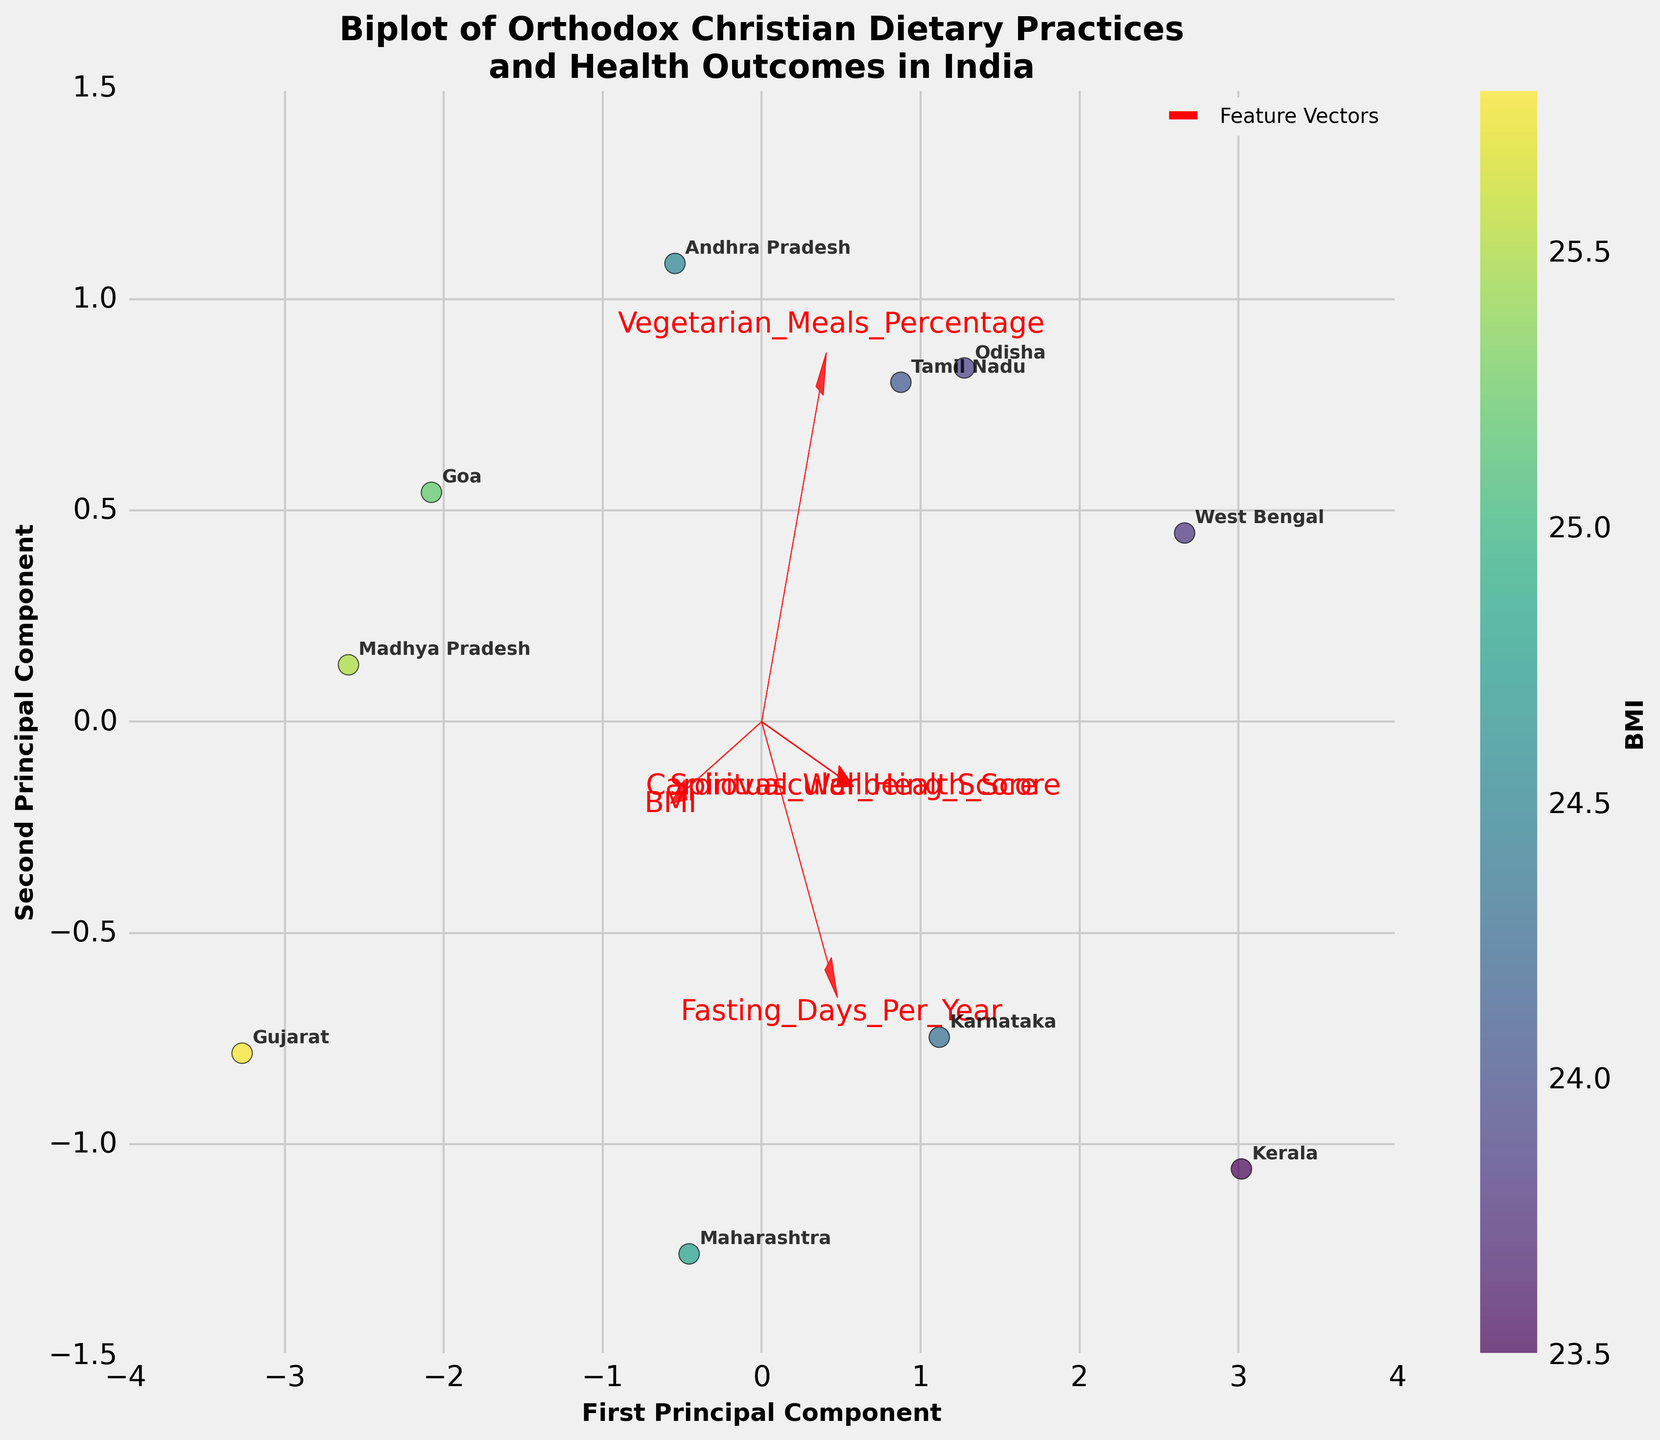What's the title of the figure? The title is located at the upper part of the figure, providing a clear indication of what the plot represents.
Answer: Biplot of Orthodox Christian Dietary Practices and Health Outcomes in India Which region has the highest BMI score based on the color shading? The regions are represented by different points, and the color coding indicates the BMI values, with a color bar beside the plot for reference. The darkest shade corresponds to the highest BMI.
Answer: Gujarat What are the two principal components labeled on the axes? The labels of the axes indicate which principal components are being plotted along each axis, usually with clear text.
Answer: First Principal Component and Second Principal Component Which feature vector has the largest positive value on the first principal component? Feature vectors are represented by arrows, with the direction and length indicating their relationship to the principal components. The feature vector extending furthest in the positive direction of the first principal component has the largest value.
Answer: Fasting_Days_Per_Year How many regions are plotted in the figure? Each region is represented by a labeled data point on the plot. Counting these labeled points provides the number of regions.
Answer: 10 Which region has the highest Spiritual Wellbeing Score? The data points are annotated with region labels, and the red feature vectors indicate how Spiritual Wellbeing Score is projected in the plot. The data point farthest in the positive direction of this vector corresponds to the highest score.
Answer: Kerala Does Tamil Nadu or Maharashtra have a higher Cardiovascular Health Score based on their positions? The positions of the data points along the red Cardiovascular Health Score vector indicate their values for this feature. The data point further along this vector has a higher score.
Answer: Tamil Nadu What relationship can be inferred between Vegetarian Meals Percentage and BMI? Both features are represented by red arrows, and their relative directions and positions provide insights into the correlation. If the arrows are opposite, it suggests a negative correlation, and if similar, a positive correlation.
Answer: Negative correlation Which feature vector is closest to the axis of the second principal component? The feature vector whose arrow is closest to being parallel with the second principal component axis indicates a strong relationship with this component.
Answer: Spiritual_Wellbeing_Score Which region has the most similar fasting days per year and vegetarian meals percentage? By looking at the positions of the data points relative to both the Fasting_Days_Per_Year and Vegetarian_Meals_Percentage vectors, one can determine which regions are closely aligned with both.
Answer: West Bengal 